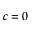Convert formula to latex. <formula><loc_0><loc_0><loc_500><loc_500>c = 0</formula> 